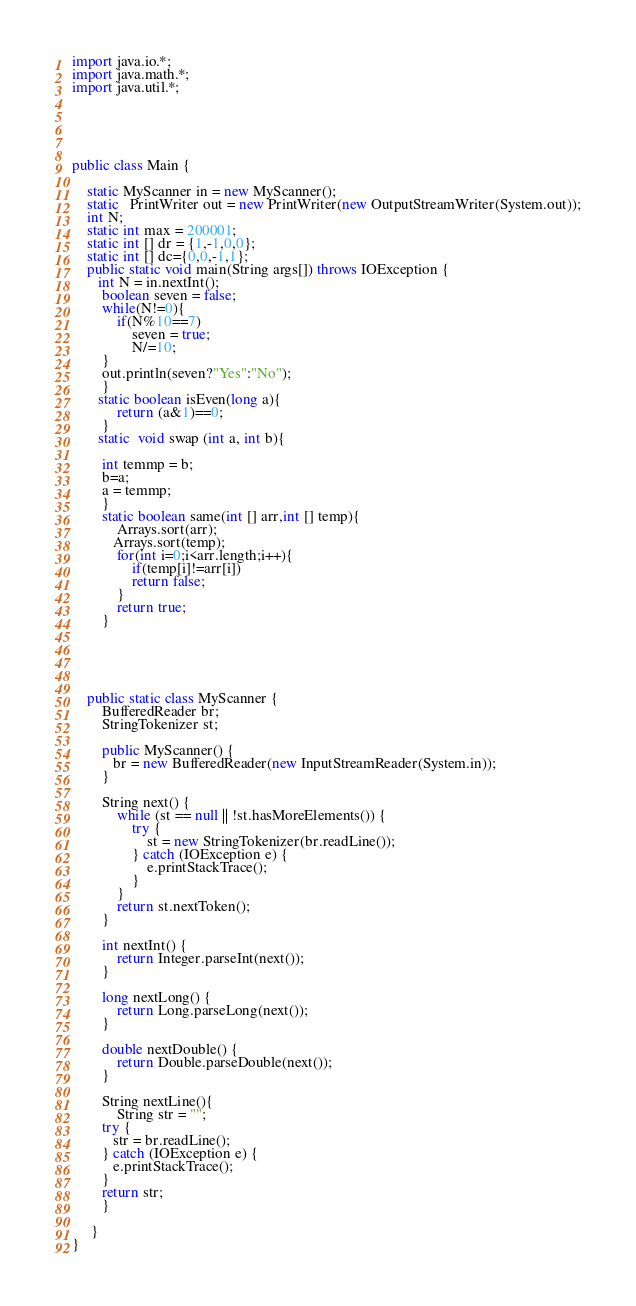<code> <loc_0><loc_0><loc_500><loc_500><_Java_>import java.io.*;
import java.math.*;
import java.util.*;





public class Main {

    static MyScanner in = new MyScanner();
    static   PrintWriter out = new PrintWriter(new OutputStreamWriter(System.out));
    int N;
    static int max = 200001;
    static int [] dr = {1,-1,0,0};
    static int [] dc={0,0,-1,1};
    public static void main(String args[]) throws IOException {
       int N = in.nextInt();
        boolean seven = false;
        while(N!=0){
            if(N%10==7)
                seven = true;
                N/=10;
        }
        out.println(seven?"Yes":"No");
        }
       static boolean isEven(long a){
            return (a&1)==0;
        }
       static  void swap (int a, int b){

        int temmp = b;
        b=a;
        a = temmp;
        }
        static boolean same(int [] arr,int [] temp){
            Arrays.sort(arr);
           Arrays.sort(temp);
            for(int i=0;i<arr.length;i++){
                if(temp[i]!=arr[i])
                return false;
            }
            return true;
        }

 
  


    public static class MyScanner {
        BufferedReader br;
        StringTokenizer st;
   
        public MyScanner() {
           br = new BufferedReader(new InputStreamReader(System.in));
        }
   
        String next() {
            while (st == null || !st.hasMoreElements()) {
                try {
                    st = new StringTokenizer(br.readLine());
                } catch (IOException e) {
                    e.printStackTrace();
                }
            }
            return st.nextToken();
        }
   
        int nextInt() {
            return Integer.parseInt(next());
        }
   
        long nextLong() {
            return Long.parseLong(next());
        }
   
        double nextDouble() {
            return Double.parseDouble(next());
        }
   
        String nextLine(){
            String str = "";
        try {
           str = br.readLine();
        } catch (IOException e) {
           e.printStackTrace();
        }
        return str;
        }
  
     }
}</code> 